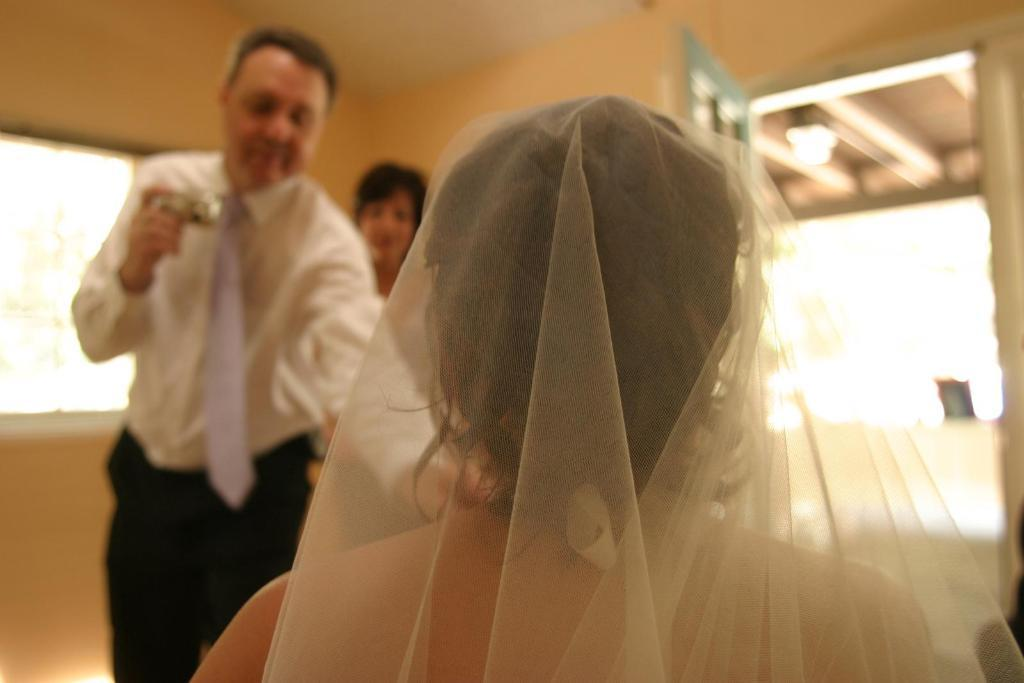What are the people in the image doing? The people in the image are standing. Can you identify any specific objects that one of the people is holding? Yes, one person is holding a camera. What architectural features can be seen in the image? There is a door and walls visible in the image. What part of the natural environment is visible in the image? The sky is visible in the image. Can you describe the position of the woman in the image? There is a woman sitting in the foreground of the image. What type of snake can be seen slithering on the tree in the image? There is no snake or tree present in the image. What is the woman's opinion on the current political situation in the image? The image does not provide any information about the woman's opinion on the current political situation. 